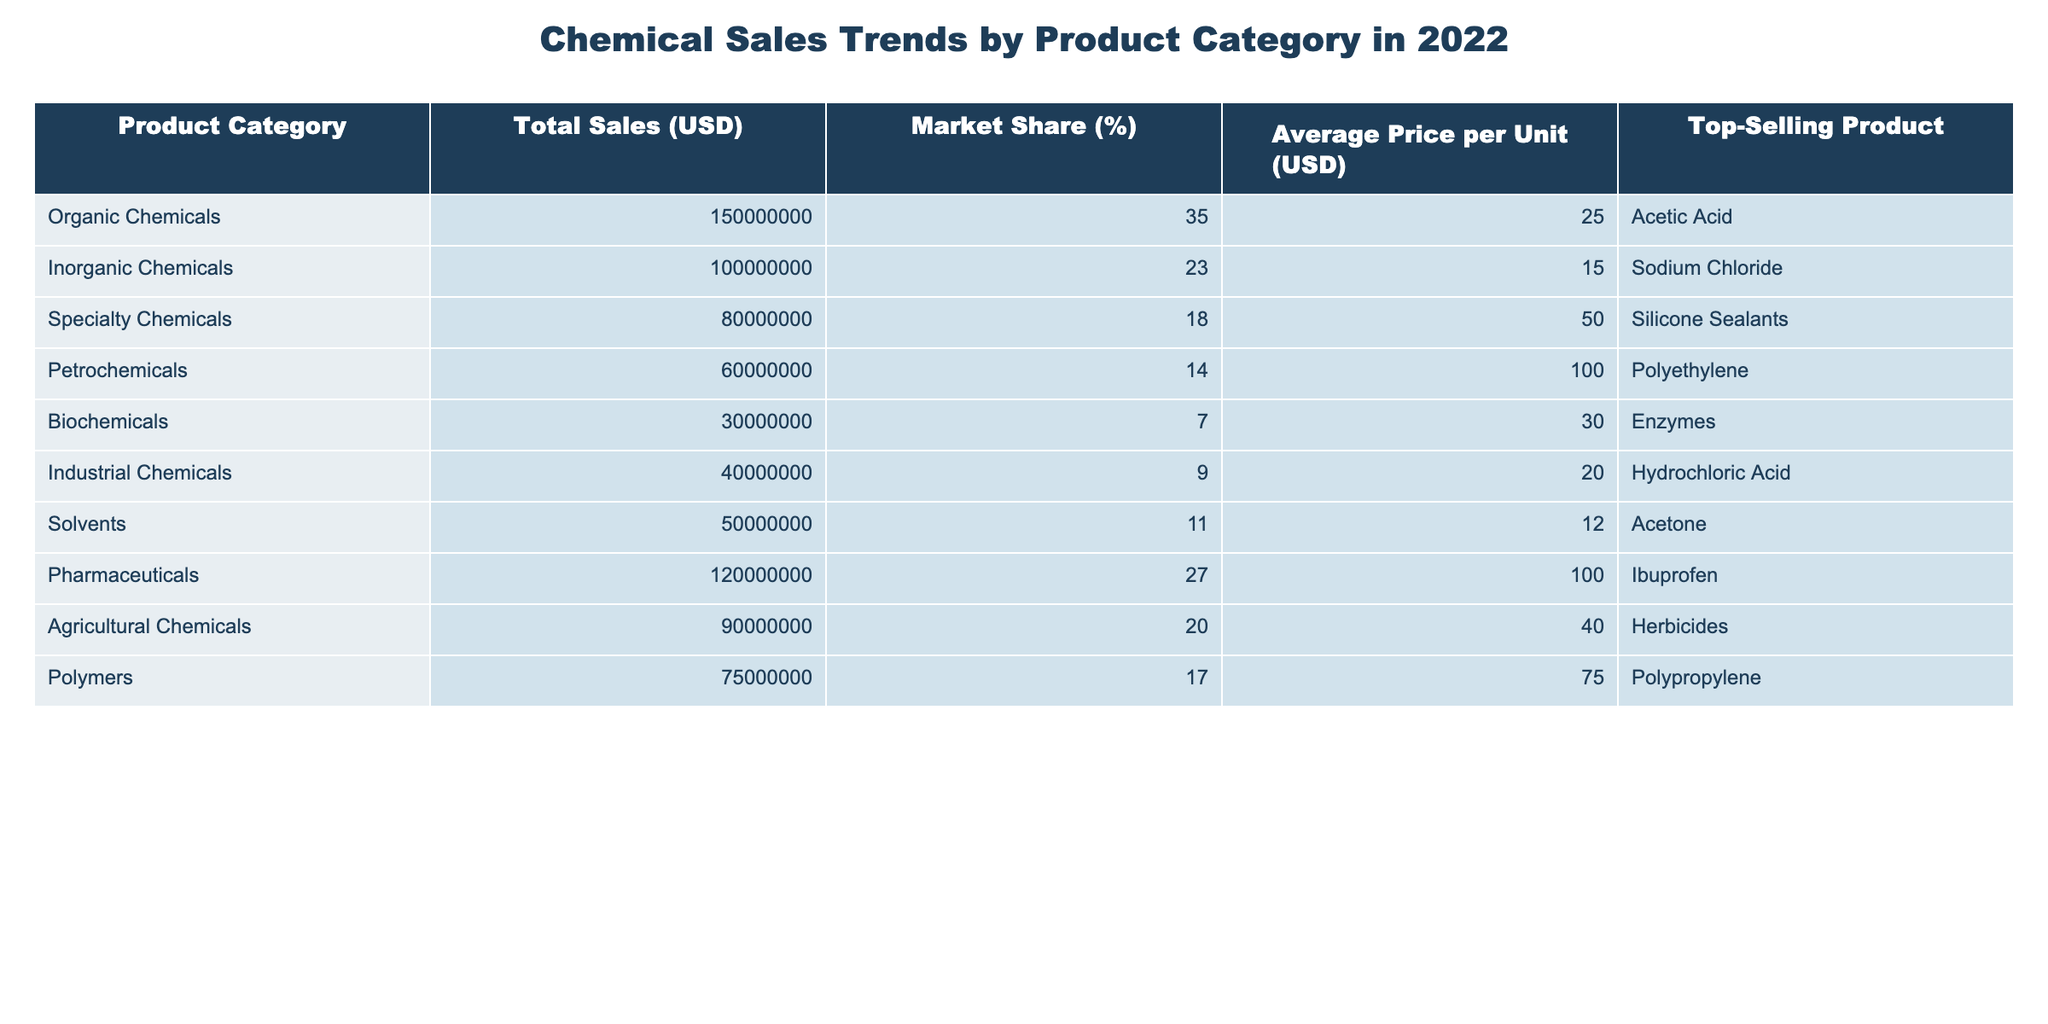What is the total sales value for Organic Chemicals? According to the table, the total sales for Organic Chemicals is listed as 150,000,000 USD.
Answer: 150,000,000 USD Which product has the highest market share? Looking through the market share percentages, Organic Chemicals have the highest market share at 35%.
Answer: Organic Chemicals What is the average price per unit for Pharmaceuticals? The table indicates that the average price per unit for Pharmaceuticals is 100 USD.
Answer: 100 USD What is the difference in total sales between Inorganic Chemicals and Specialty Chemicals? Total sales for Inorganic Chemicals is 100,000,000 USD and for Specialty Chemicals is 80,000,000 USD. The difference is 100,000,000 - 80,000,000 = 20,000,000 USD.
Answer: 20,000,000 USD Which product category has the highest average price per unit, and what is that price? The highest average price per unit is found in Petrochemicals at 100 USD.
Answer: Petrochemicals, 100 USD Is the market share of Biochemicals greater than 10%? The market share for Biochemicals is 7%, which is less than 10%.
Answer: No What is the total market share for all the chemical categories listed? By adding all the market shares: 35 + 23 + 18 + 14 + 7 + 9 + 11 + 27 + 20 + 17 = 181%. The total market share exceeds 100% due to the combined representation of overlapping segments in the market.
Answer: 181% If you combine the total sales of Agricultural Chemicals and Solvents, what is the total? Agricultural Chemicals total sales is 90,000,000 USD and Solvents total sales is 50,000,000 USD. Thus, their combined total is 90,000,000 + 50,000,000 = 140,000,000 USD.
Answer: 140,000,000 USD What is the top-selling product in the Specialty Chemicals category? The table states that the top-selling product in the Specialty Chemicals category is Silicone Sealants.
Answer: Silicone Sealants How many product categories have total sales greater than 70 million USD? The total sales greater than 70 million USD are for Organic Chemicals, Inorganic Chemicals, Pharmaceuticals, and Agricultural Chemicals. There are 4 categories with total sales greater than 70 million USD.
Answer: 4 